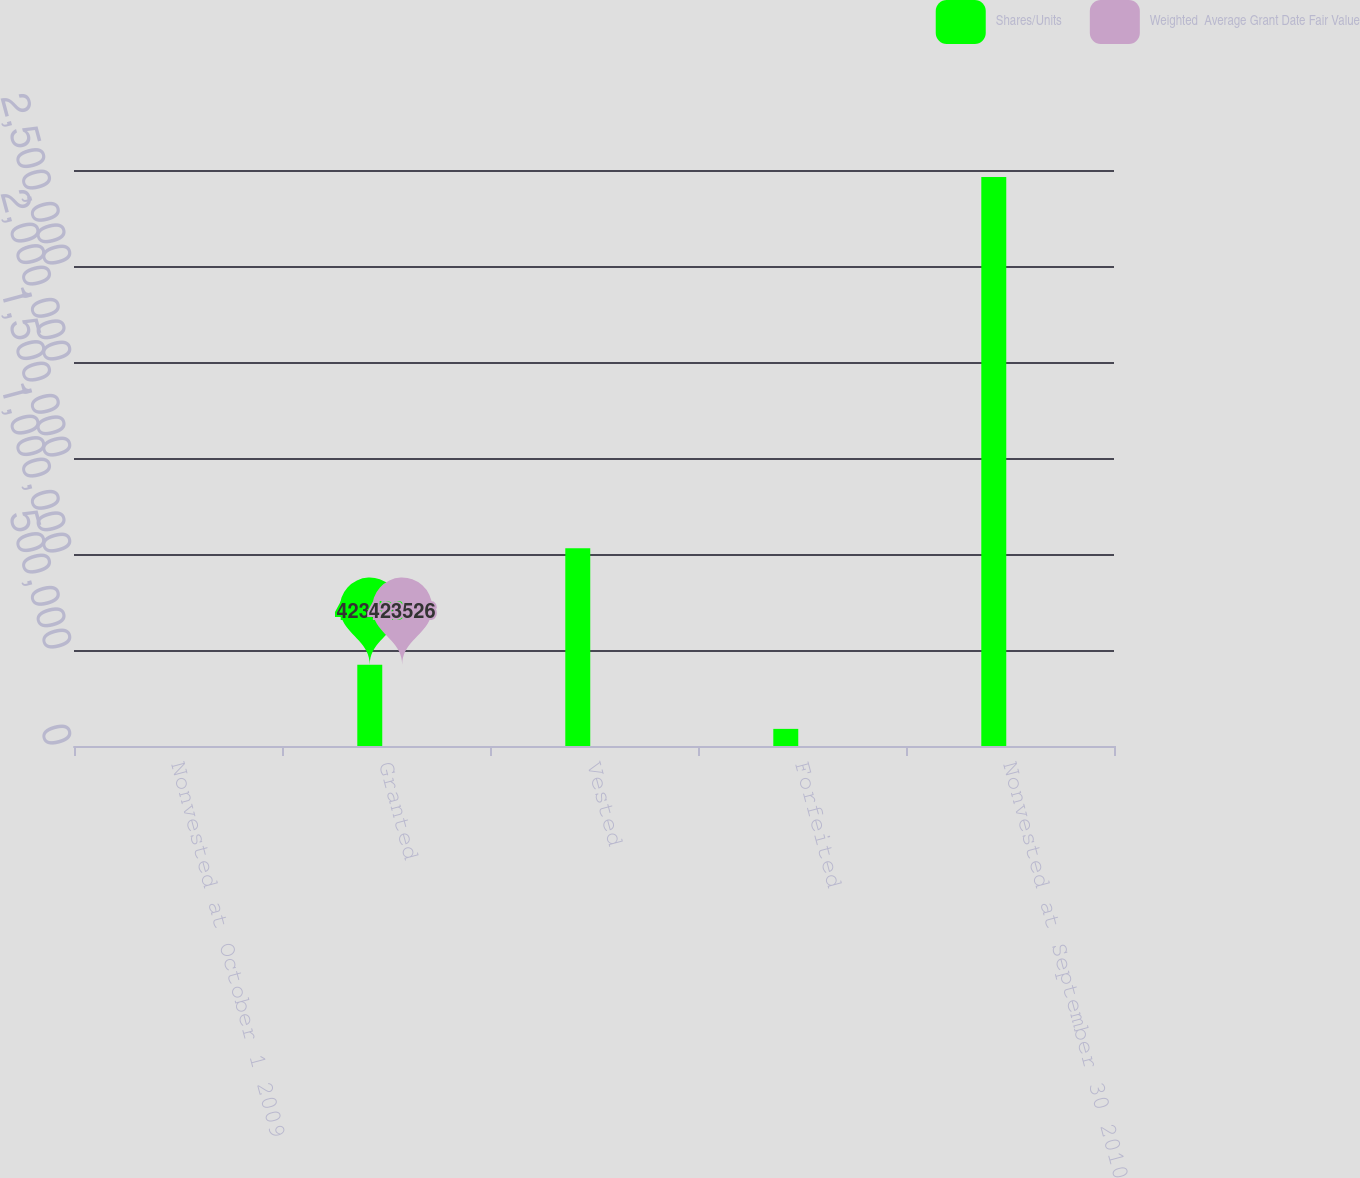<chart> <loc_0><loc_0><loc_500><loc_500><stacked_bar_chart><ecel><fcel>Nonvested at October 1 2009<fcel>Granted<fcel>Vested<fcel>Forfeited<fcel>Nonvested at September 30 2010<nl><fcel>Shares/Units<fcel>25.58<fcel>423526<fcel>1.03036e+06<fcel>89215<fcel>2.96406e+06<nl><fcel>Weighted  Average Grant Date Fair Value<fcel>25.18<fcel>25.17<fcel>24.1<fcel>24.38<fcel>25.58<nl></chart> 